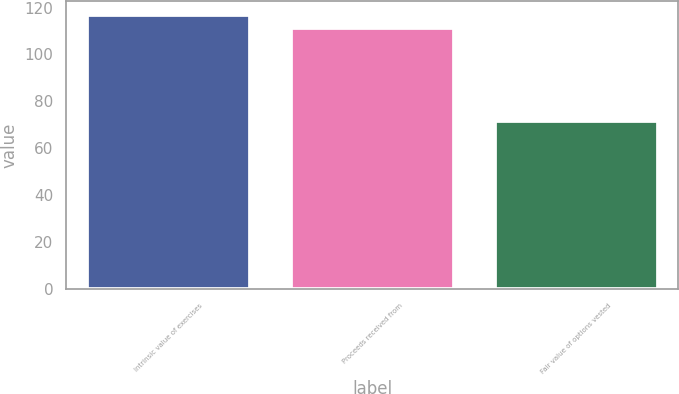Convert chart. <chart><loc_0><loc_0><loc_500><loc_500><bar_chart><fcel>Intrinsic value of exercises<fcel>Proceeds received from<fcel>Fair value of options vested<nl><fcel>116.9<fcel>111.1<fcel>71.8<nl></chart> 